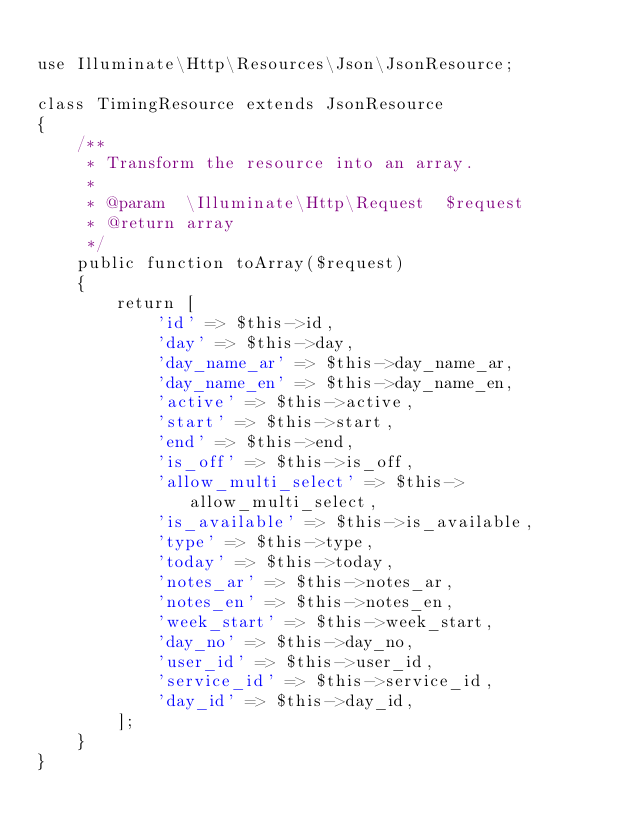Convert code to text. <code><loc_0><loc_0><loc_500><loc_500><_PHP_>
use Illuminate\Http\Resources\Json\JsonResource;

class TimingResource extends JsonResource
{
    /**
     * Transform the resource into an array.
     *
     * @param  \Illuminate\Http\Request  $request
     * @return array
     */
    public function toArray($request)
    {
        return [
            'id' => $this->id,
            'day' => $this->day,
            'day_name_ar' => $this->day_name_ar,
            'day_name_en' => $this->day_name_en,
            'active' => $this->active,
            'start' => $this->start,
            'end' => $this->end,
            'is_off' => $this->is_off,
            'allow_multi_select' => $this->allow_multi_select,
            'is_available' => $this->is_available,
            'type' => $this->type,
            'today' => $this->today,
            'notes_ar' => $this->notes_ar,
            'notes_en' => $this->notes_en,
            'week_start' => $this->week_start,
            'day_no' => $this->day_no,
            'user_id' => $this->user_id,
            'service_id' => $this->service_id,
            'day_id' => $this->day_id,
        ];
    }
}
</code> 